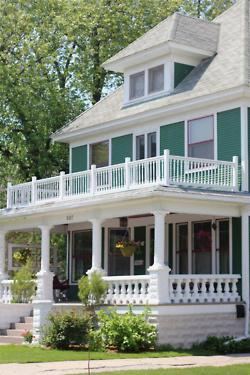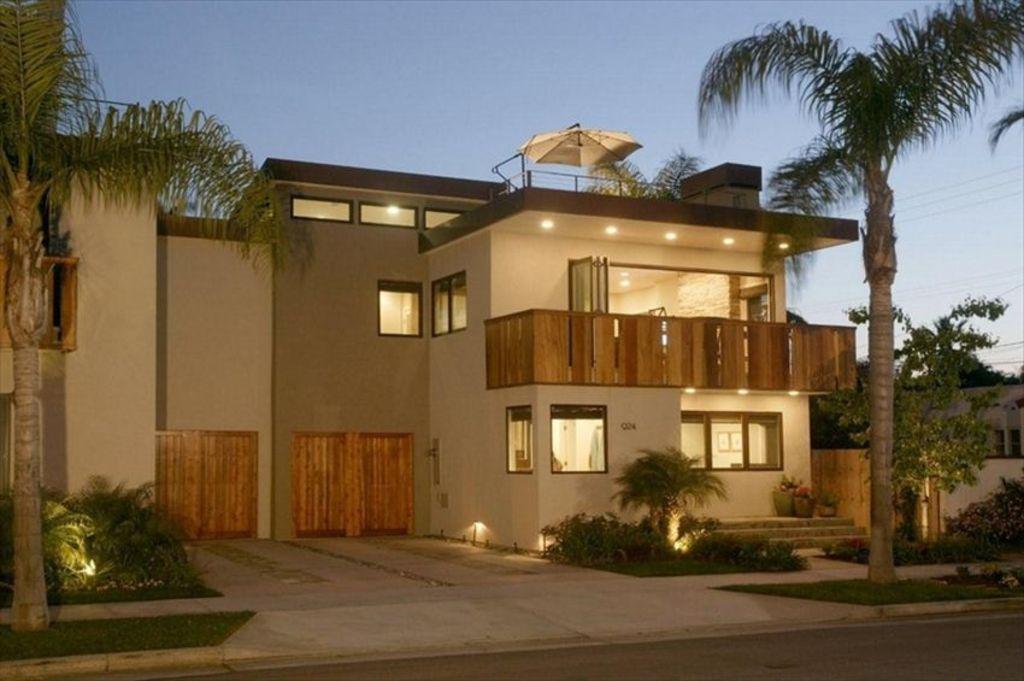The first image is the image on the left, the second image is the image on the right. For the images shown, is this caption "The left and right image contains the same number of stories on a single home." true? Answer yes or no. Yes. 